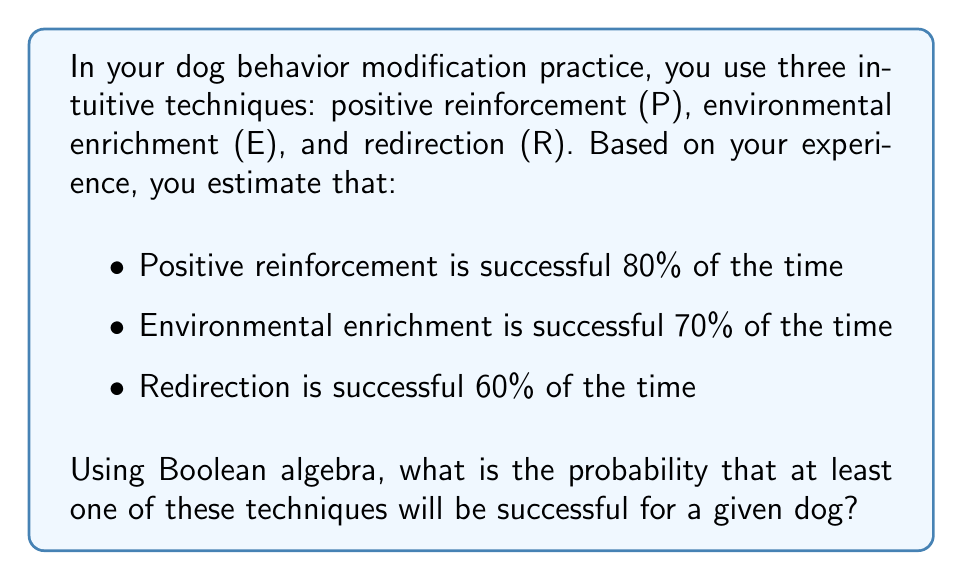What is the answer to this math problem? To solve this problem using Boolean algebra, we'll follow these steps:

1) First, let's define our events:
   P: Positive reinforcement is successful
   E: Environmental enrichment is successful
   R: Redirection is successful

2) We're looking for the probability that at least one technique is successful. In Boolean terms, this is equivalent to P OR E OR R.

3) The probability of this can be calculated using the inclusion-exclusion principle:

   $$P(P \lor E \lor R) = P(P) + P(E) + P(R) - P(P \land E) - P(P \land R) - P(E \land R) + P(P \land E \land R)$$

4) We know:
   $P(P) = 0.8$
   $P(E) = 0.7$
   $P(R) = 0.6$

5) Assuming independence between the techniques, we can calculate:
   $P(P \land E) = P(P) \cdot P(E) = 0.8 \cdot 0.7 = 0.56$
   $P(P \land R) = P(P) \cdot P(R) = 0.8 \cdot 0.6 = 0.48$
   $P(E \land R) = P(E) \cdot P(R) = 0.7 \cdot 0.6 = 0.42$
   $P(P \land E \land R) = P(P) \cdot P(E) \cdot P(R) = 0.8 \cdot 0.7 \cdot 0.6 = 0.336$

6) Now we can substitute these values into our equation:

   $$P(P \lor E \lor R) = 0.8 + 0.7 + 0.6 - 0.56 - 0.48 - 0.42 + 0.336 = 0.976$$

Therefore, the probability that at least one technique will be successful is 0.976 or 97.6%.
Answer: 0.976 or 97.6% 